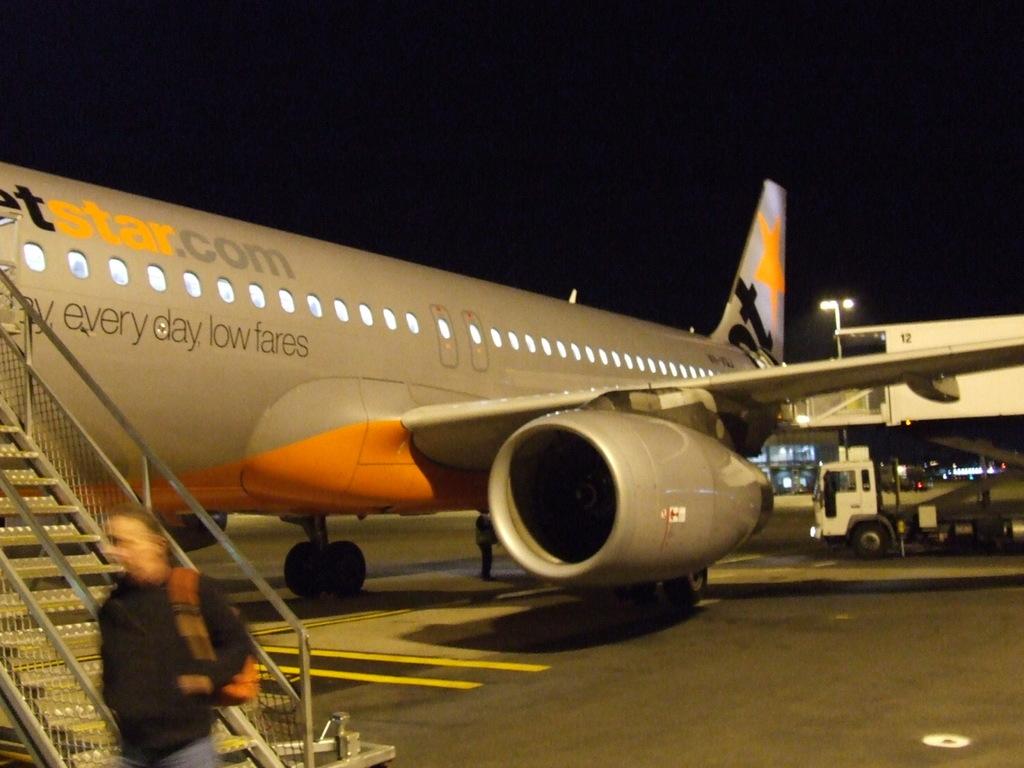What website is being advertised on the plane?
Provide a succinct answer. Jetstar.com. Which days do they have low fares?
Your answer should be very brief. Every day. 